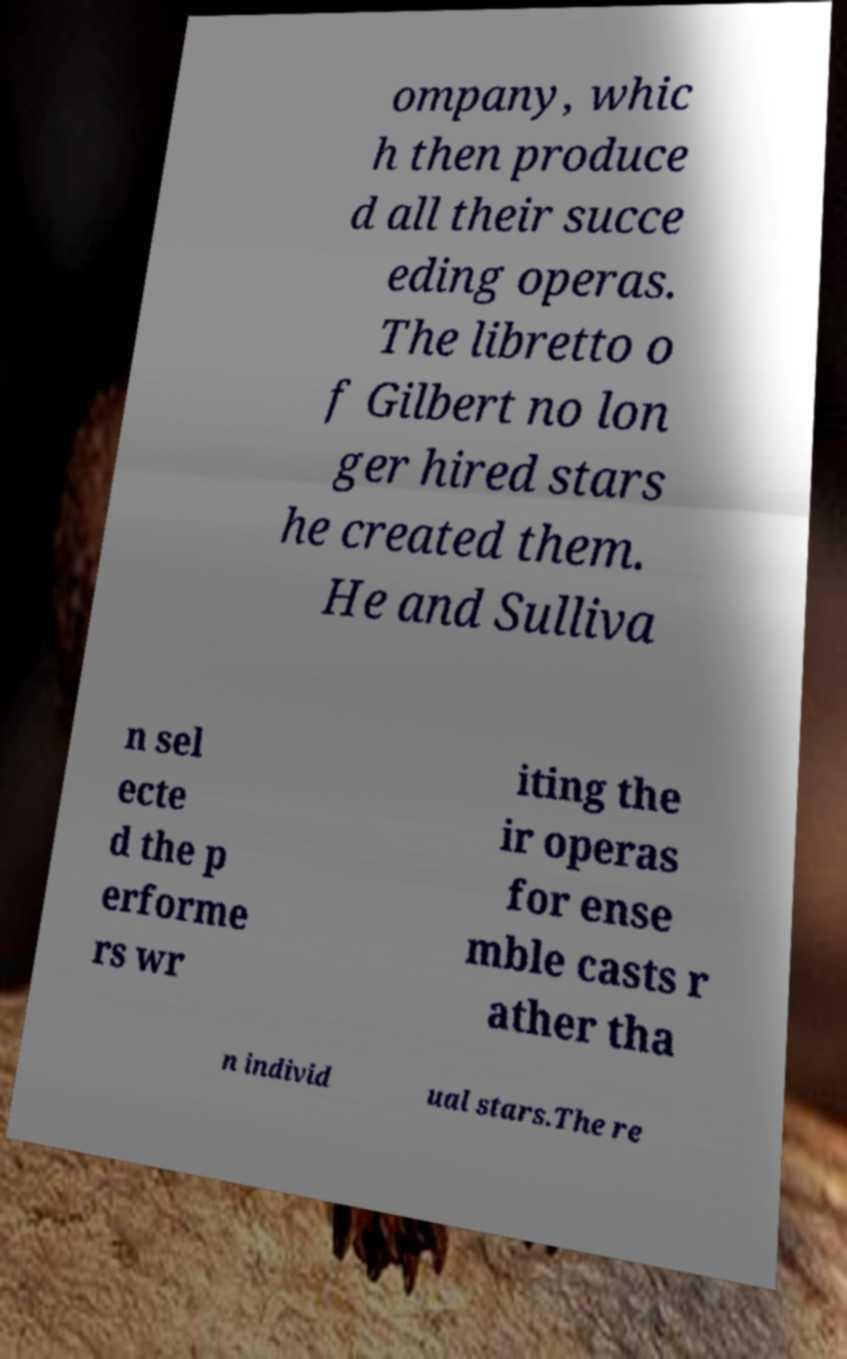For documentation purposes, I need the text within this image transcribed. Could you provide that? ompany, whic h then produce d all their succe eding operas. The libretto o f Gilbert no lon ger hired stars he created them. He and Sulliva n sel ecte d the p erforme rs wr iting the ir operas for ense mble casts r ather tha n individ ual stars.The re 